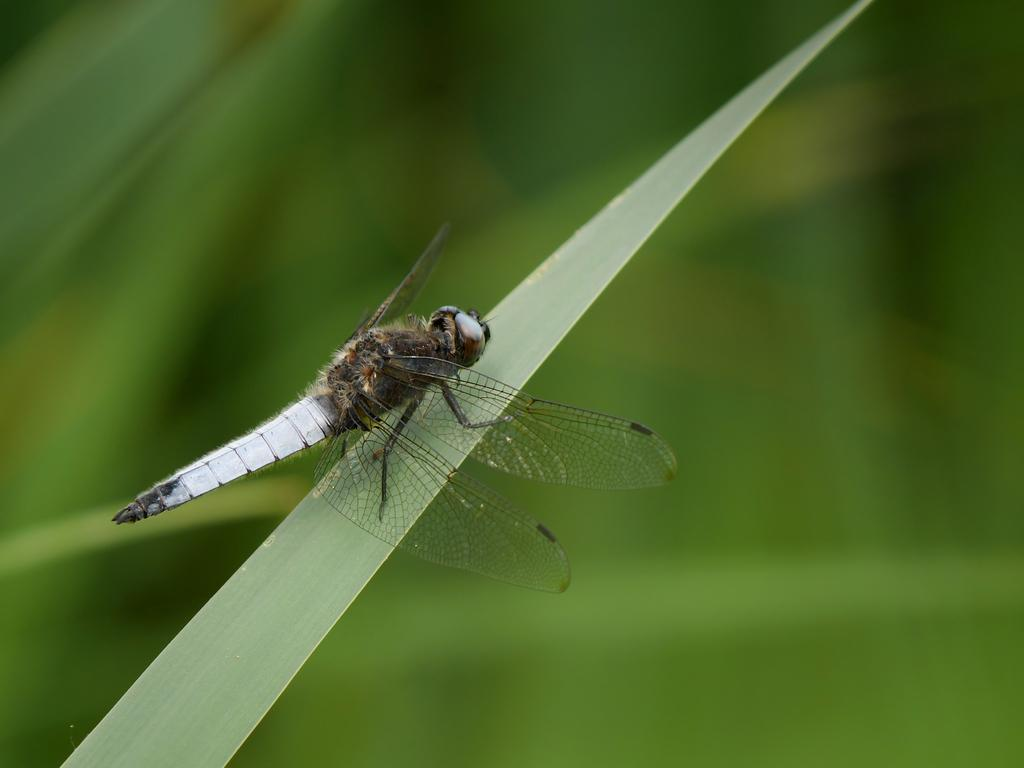What insect is present in the image? There is a dragonfly in the image. Where is the dragonfly located? The dragonfly is on the grass. Can you describe the background of the image? The background of the image is blurred. What type of frame is around the dragonfly in the image? There is no frame around the dragonfly in the image; it is not in a picture frame. 